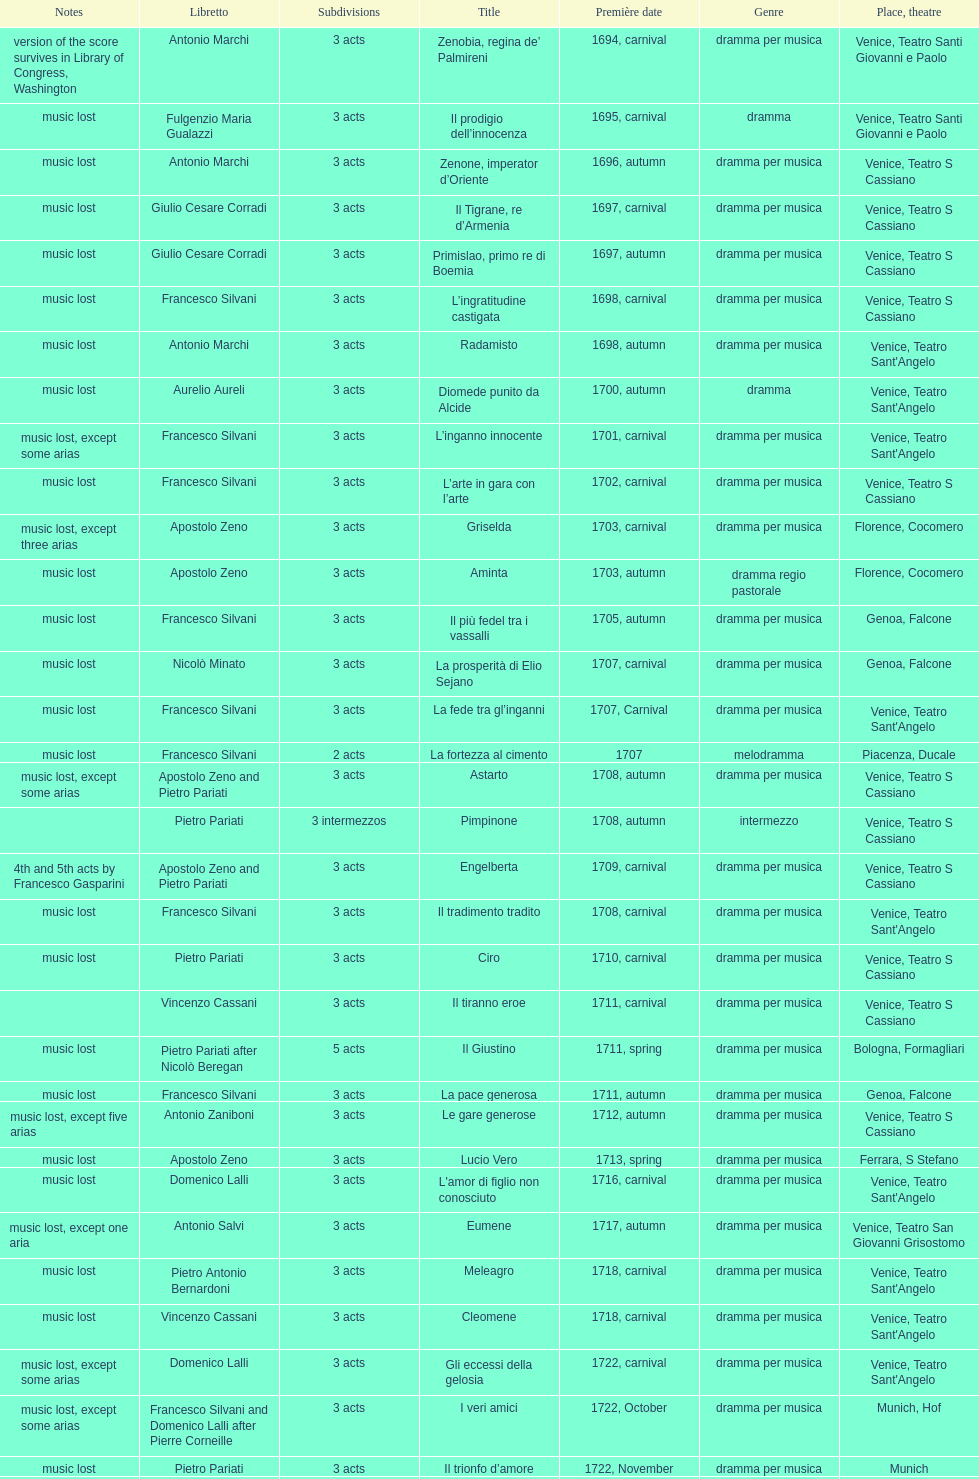L'inganno innocente premiered in 1701. what was the previous title released? Diomede punito da Alcide. 